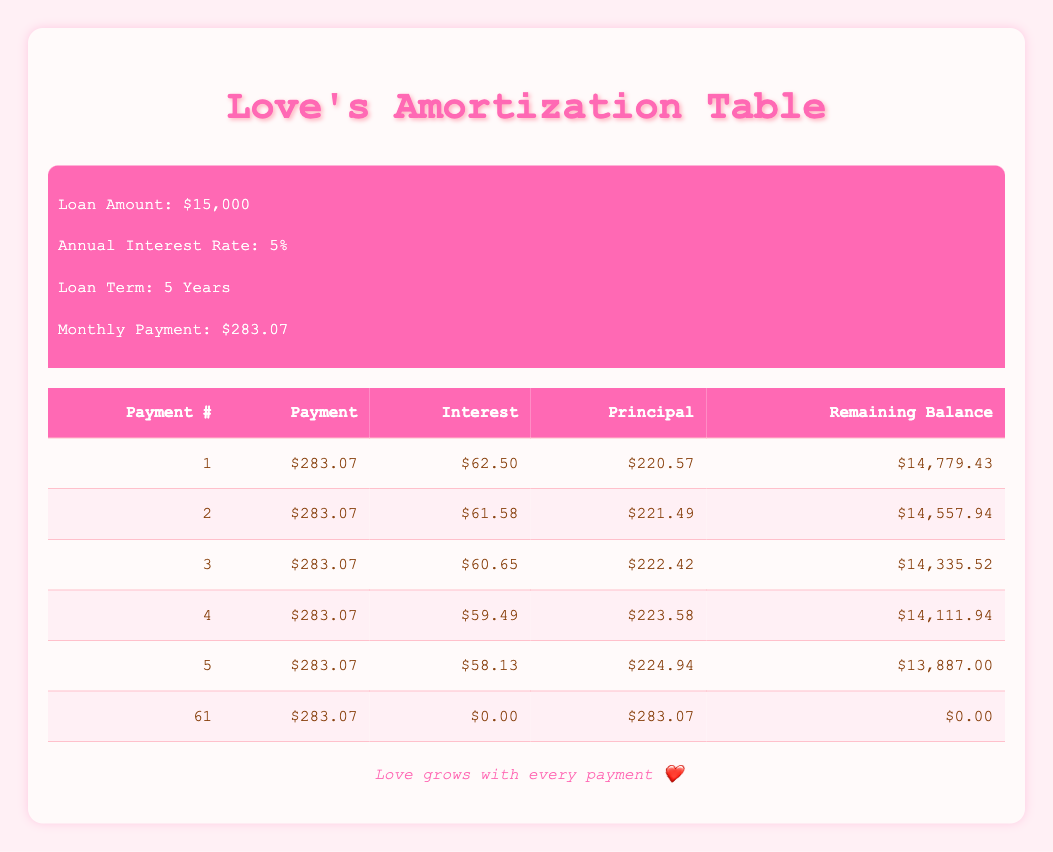What is the monthly payment for the wedding loan? The monthly payment is given directly in the table header as $283.07, meaning this is the amount that will be paid each month for the loan.
Answer: $283.07 How much of the first payment goes towards principal? In the first row of the table, the principal portion is specified as $220.57. This amount is the part of the first payment that goes towards paying off the principal of the loan.
Answer: $220.57 What is the total interest paid in the first year? To find the total interest paid in the first year, we need to sum the interest amounts for the first 12 payments: 62.50 + 61.58 + 60.65 + 59.49 + 58.13 + 57.03 + 56.03 + 53.82 + 54.23 + 53.16 + 53.10 + 52.29 = $677.53. Therefore, the total interest for the first year is $677.53.
Answer: $677.53 Is the amount of principal paid in the 10th payment greater than the amount paid in the 5th payment? The principal paid in the 10th payment is $229.91, while in the 5th payment it is $224.94. Since $229.91 is greater than $224.94, the statement is true.
Answer: Yes What is the remaining balance after the 30th payment? To find the remaining balance after the 30th payment, we refer to the table where the 30th row indicates that the remaining balance is $8174.04. This is the amount left to pay off after that specific payment.
Answer: $8174.04 How much interest is paid in total over the entire loan term? To calculate the total interest paid over the loan term, sum all interest payments from payment 1 to payment 61: 62.50 + 61.58 + ... + 0.00 = $1072.85. This adds all interest amounts to find the total paid in interest throughout the full term.
Answer: $1072.85 What is the average principal payment over the first year? The principal amounts for the first year need to be summed up and divided by the number of payments (12): (220.57 + 221.49 + ... + 230.78) sums to $2,683.37. Dividing by 12 gives an average principal payment of about $223.61 over the first year.
Answer: $223.61 Was the interest paid in the second payment less than $65? In the second payment row, the interest is listed as $61.58. Since this amount is less than $65, the statement is true.
Answer: Yes What is the total remaining balance after 6 months of payments? The remaining balance after 6 months (after the 6th payment) can be found in the 6th payment row, which shows a remaining balance of $13,660.96, referencing how much is left to pay off the loan after half a year of payments.
Answer: $13,660.96 